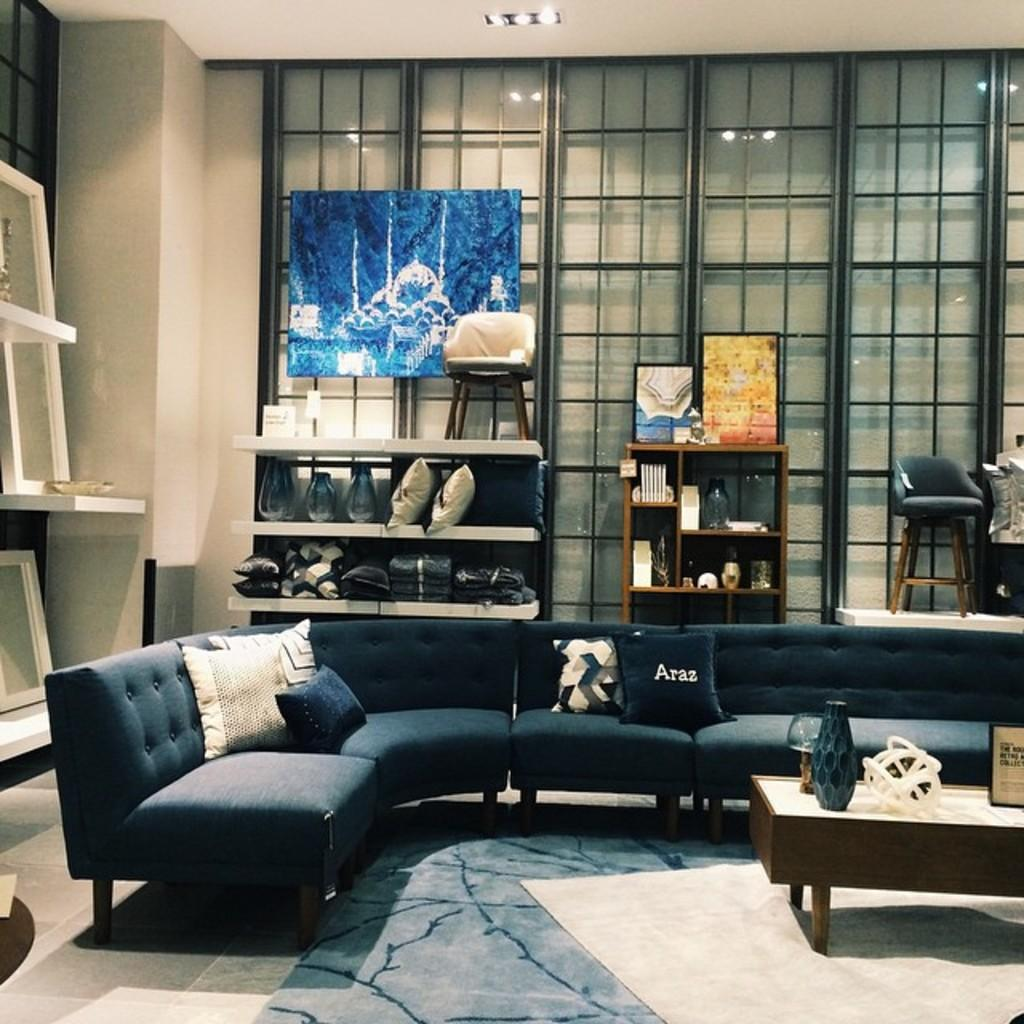What type of furniture is in the image that can be used for sitting and sleeping? There is a sofa bed in the image. What type of storage furniture is in the image? There are shelves in the image. What is displayed on the shelves? A photo frame is present on the shelves. What type of furniture is in the image that can be used for placing items? There is a table in the image. What type of lettuce is growing on the table in the image? There is no lettuce present in the image; it is a table with no plants or greenery. 